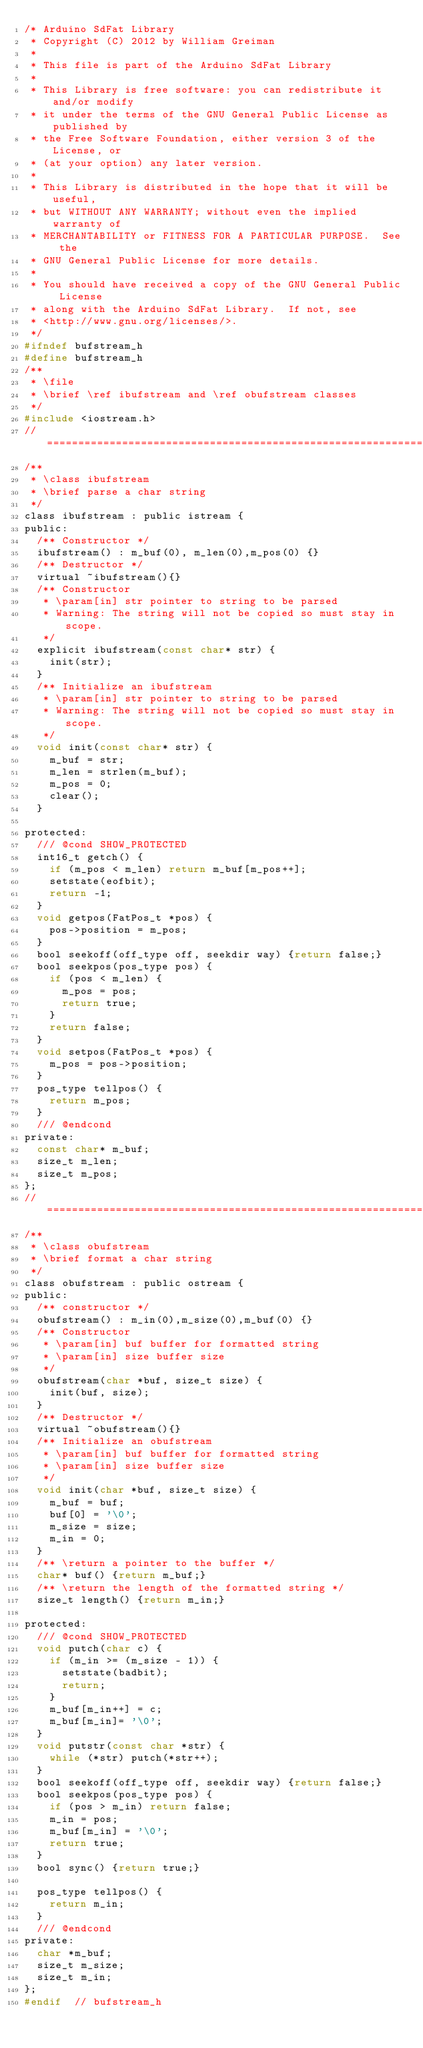Convert code to text. <code><loc_0><loc_0><loc_500><loc_500><_C_>/* Arduino SdFat Library
 * Copyright (C) 2012 by William Greiman
 *
 * This file is part of the Arduino SdFat Library
 *
 * This Library is free software: you can redistribute it and/or modify
 * it under the terms of the GNU General Public License as published by
 * the Free Software Foundation, either version 3 of the License, or
 * (at your option) any later version.
 *
 * This Library is distributed in the hope that it will be useful,
 * but WITHOUT ANY WARRANTY; without even the implied warranty of
 * MERCHANTABILITY or FITNESS FOR A PARTICULAR PURPOSE.  See the
 * GNU General Public License for more details.
 *
 * You should have received a copy of the GNU General Public License
 * along with the Arduino SdFat Library.  If not, see
 * <http://www.gnu.org/licenses/>.
 */
#ifndef bufstream_h
#define bufstream_h
/**
 * \file
 * \brief \ref ibufstream and \ref obufstream classes
 */
#include <iostream.h>
//==============================================================================
/**
 * \class ibufstream
 * \brief parse a char string
 */
class ibufstream : public istream {
public:
	/** Constructor */
	ibufstream() : m_buf(0), m_len(0),m_pos(0) {}
	/** Destructor */
	virtual ~ibufstream(){}
	/** Constructor
	 * \param[in] str pointer to string to be parsed
	 * Warning: The string will not be copied so must stay in scope.
	 */
	explicit ibufstream(const char* str) {
		init(str);
	}
	/** Initialize an ibufstream
	 * \param[in] str pointer to string to be parsed
	 * Warning: The string will not be copied so must stay in scope.
	 */
	void init(const char* str) {
		m_buf = str;
		m_len = strlen(m_buf);
		m_pos = 0;
		clear();
	}

protected:
	/// @cond SHOW_PROTECTED
	int16_t getch() {
		if (m_pos < m_len) return m_buf[m_pos++];
		setstate(eofbit);
		return -1;
	}
	void getpos(FatPos_t *pos) {
		pos->position = m_pos;
	}
	bool seekoff(off_type off, seekdir way) {return false;}
	bool seekpos(pos_type pos) {
		if (pos < m_len) {
			m_pos = pos;
			return true;
		}
		return false;
	}
	void setpos(FatPos_t *pos) {
		m_pos = pos->position;
	}
	pos_type tellpos() {
		return m_pos;
	}
	/// @endcond
private:
	const char* m_buf;
	size_t m_len;
	size_t m_pos;
};
//==============================================================================
/**
 * \class obufstream
 * \brief format a char string
 */
class obufstream : public ostream {
public:
	/** constructor */
	obufstream() : m_in(0),m_size(0),m_buf(0) {}
	/** Constructor
	 * \param[in] buf buffer for formatted string
	 * \param[in] size buffer size
	 */
	obufstream(char *buf, size_t size) {
		init(buf, size);
	}
	/** Destructor */
	virtual ~obufstream(){}
	/** Initialize an obufstream
	 * \param[in] buf buffer for formatted string
	 * \param[in] size buffer size
	 */
	void init(char *buf, size_t size) {
		m_buf = buf;
		buf[0] = '\0';
		m_size = size;
		m_in = 0;
	}
	/** \return a pointer to the buffer */
	char* buf() {return m_buf;}
	/** \return the length of the formatted string */
	size_t length() {return m_in;}

protected:
	/// @cond SHOW_PROTECTED
	void putch(char c) {
		if (m_in >= (m_size - 1)) {
			setstate(badbit);
			return;
		}
		m_buf[m_in++] = c;
		m_buf[m_in]= '\0';
	}
	void putstr(const char *str) {
		while (*str) putch(*str++);
	}
	bool seekoff(off_type off, seekdir way) {return false;}
	bool seekpos(pos_type pos) {
		if (pos > m_in) return false;
		m_in = pos;
		m_buf[m_in] = '\0';
		return true;
	}
	bool sync() {return true;}

	pos_type tellpos() {
		return m_in;
	}
	/// @endcond
private:
	char *m_buf;
	size_t m_size;
	size_t m_in;
};
#endif  // bufstream_h
</code> 